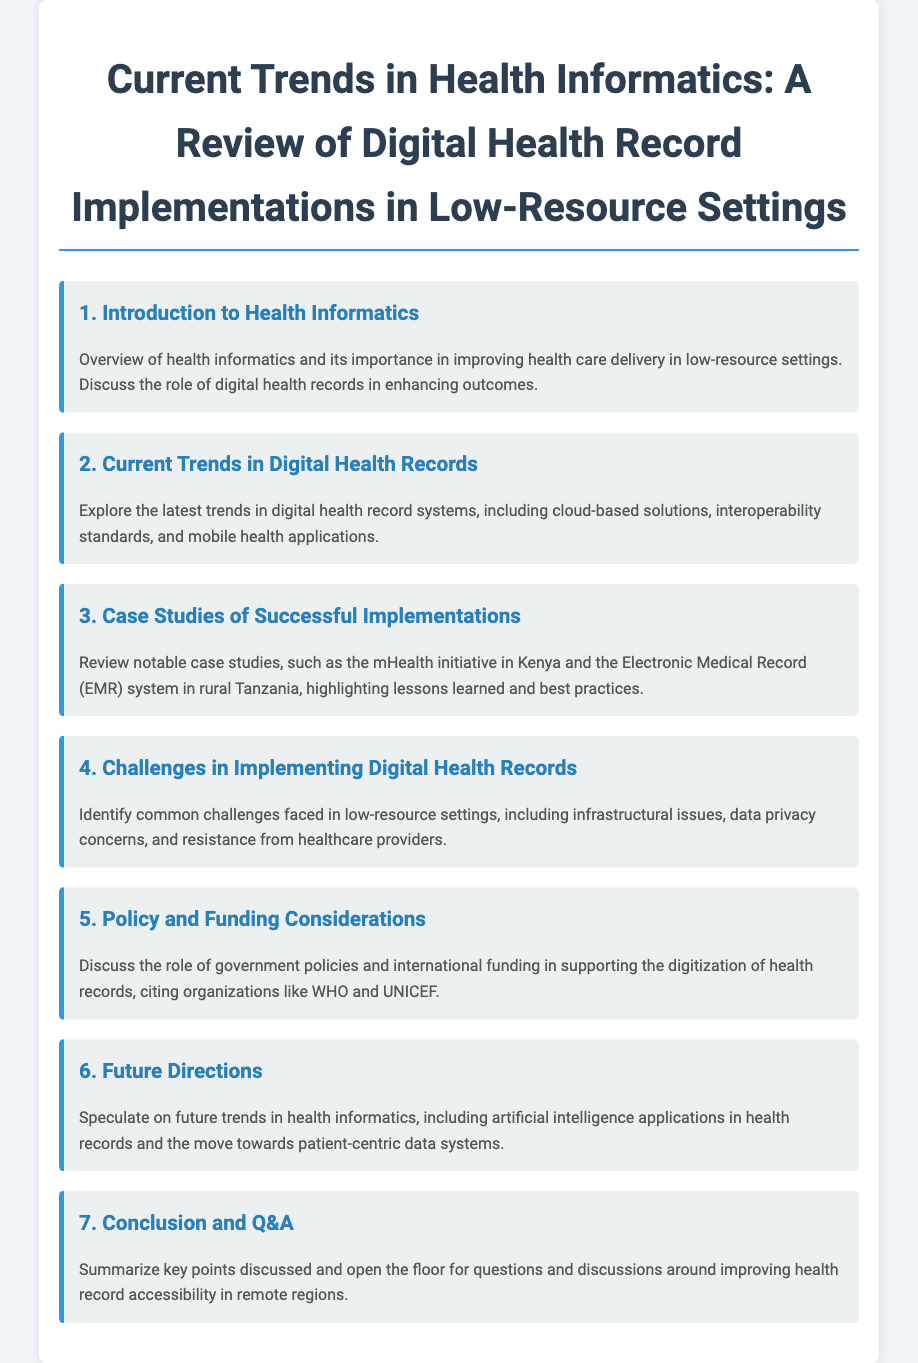What is the title of the agenda? The title provides the main focus of the document on health informatics in low-resource settings.
Answer: Current Trends in Health Informatics: A Review of Digital Health Record Implementations in Low-Resource Settings Who are the organizations mentioned in the policy considerations? The agenda highlights significant organizations that influence policy and funding for health record digitization.
Answer: WHO and UNICEF How many main agenda items are there? The document outlines the main sections of the agenda, each numbered as an item.
Answer: 7 What is the subject of the first agenda item? The first agenda item introduces the overarching theme of the document, focusing on health informatics.
Answer: Introduction to Health Informatics What initiative is highlighted as a successful case study? The agenda specifies notable case studies demonstrating successful digital health record implementations.
Answer: mHealth initiative in Kenya What common challenge is identified in the implementation of digital health records? The document describes specific issues that may arise when trying to implement health informatics solutions.
Answer: Infrastructural issues What future trend in health informatics is speculated upon? The agenda anticipates upcoming developments in the field of health informatics related to patient data.
Answer: Artificial intelligence applications in health records 